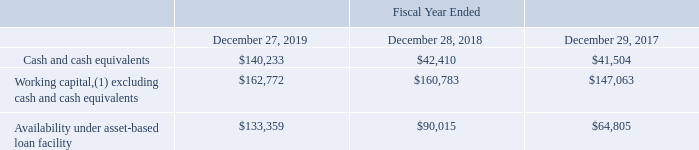Liquidity
The following table presents selected financial information on liquidity (in thousands):
(1) We define working capital as current assets less current liabilities. Fiscal year 2019 includes the impact of recognizing operating lease right-of-use assets and liabilities as a result of our adoption of Accounting Standards Codification Topic 842, “Leases,” as of December 29, 2018.
We believe our existing balances of cash and cash equivalents, working capital and the availability under our asset-based loan facility, are sufficient to satisfy our working capital needs, capital expenditures, debt service and other liquidity requirements associated with our current operations over the next 12 months.
Our capital expenditures, excluding cash paid for acquisitions, were approximately $16.1 million for fiscal 2019. We believe our capital expenditures, excluding cash paid for acquisitions, for fiscal 2020 will be approximately $38.0 million to $42.0 million. The increase in projected capital expenditures in fiscal 2020 as compared to fiscal 2019 is the result of planned expansions of several of our distribution facilities. Our planned capital projects will provide both new and expanded facilities and improvements to our technology that we believe will produce increased efficiency and the capacity to continue to support the growth of our customer base.
What is the Cash and cash equivalents for fiscal years 2019, 2018 and 2017 respectively?
Answer scale should be: thousand. $140,233, $42,410, $41,504. What is the Working capital, excluding cash and cash equivalents for fiscal years 2019, 2018 and 2017 respectively?
Answer scale should be: thousand. $162,772, $160,783, $147,063. What is the Availability under asset-based loan facility for fiscal years 2019, 2018 and 2017 respectively?
Answer scale should be: thousand. $133,359, $90,015, $64,805. What is the average value for the Cash and cash equivalents for fiscal years 2019, 2018 and 2017?
Answer scale should be: thousand. (140,233+ 42,410+ 41,504)/3
Answer: 74715.67. What is the average value for the Availability under asset-based loan facility for fiscal years 2019, 2018 and 2017?
Answer scale should be: thousand. (133,359+ 90,015+ 64,805)/3
Answer: 96059.67. Which year has the highest Cash and cash equivalents? 140,233> 42,410> 41,504
Answer: 2019. 